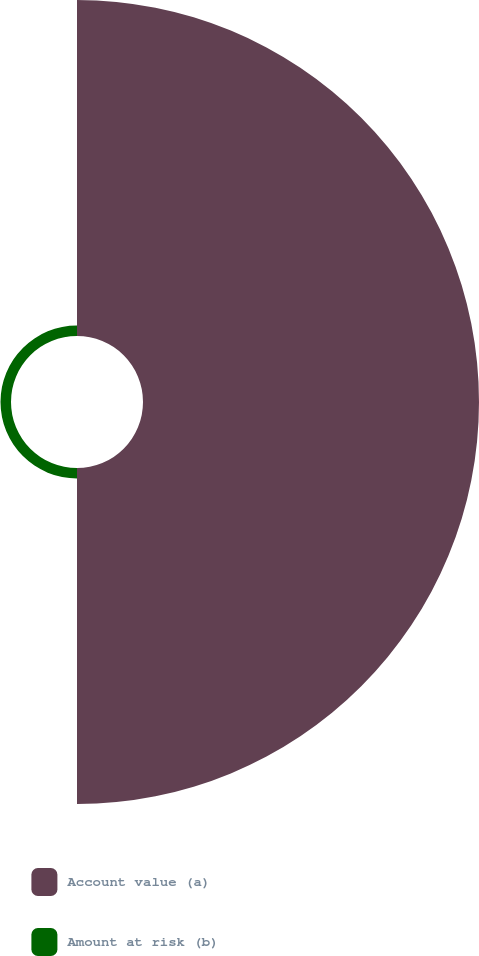Convert chart. <chart><loc_0><loc_0><loc_500><loc_500><pie_chart><fcel>Account value (a)<fcel>Amount at risk (b)<nl><fcel>96.97%<fcel>3.03%<nl></chart> 